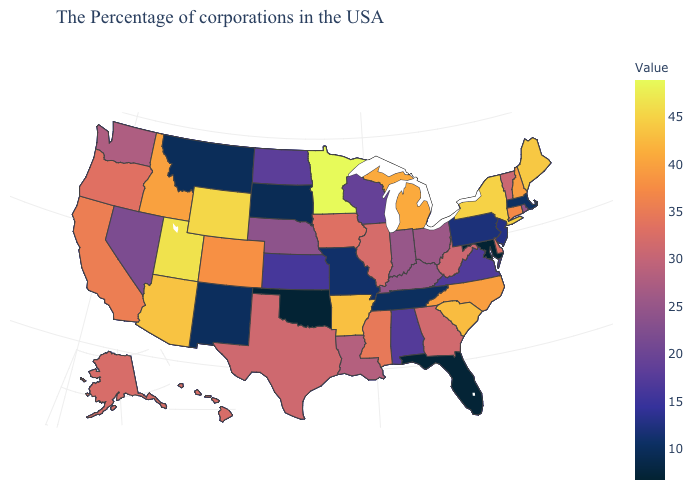Which states have the highest value in the USA?
Short answer required. Minnesota. Among the states that border Nebraska , does Iowa have the highest value?
Quick response, please. No. Does the map have missing data?
Answer briefly. No. Is the legend a continuous bar?
Short answer required. Yes. 